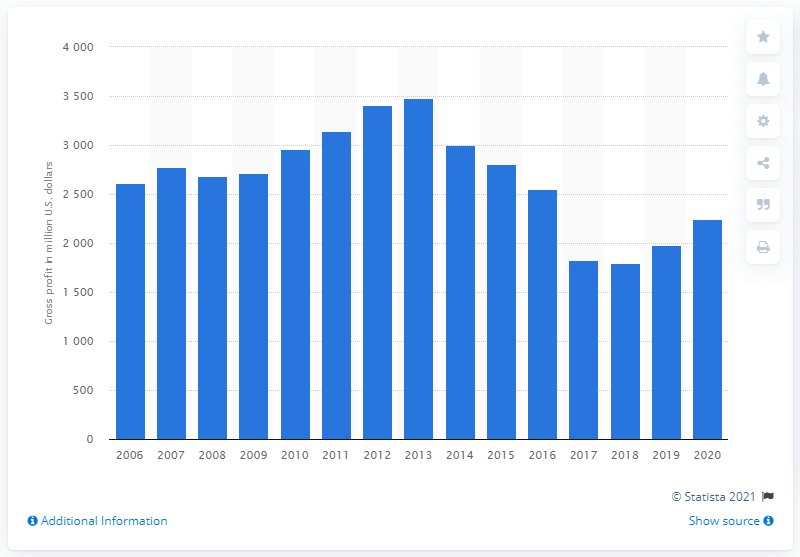Mention a couple of crucial points in this snapshot. Mattel's gross profit in 2020 was $2243.6 million. 